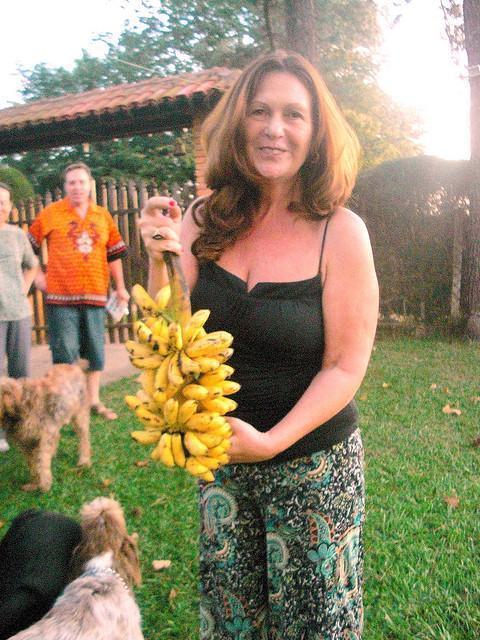How many people can you see?
Give a very brief answer. 3. How many dogs can you see?
Give a very brief answer. 3. How many pieces of cheese pizza are there?
Give a very brief answer. 0. 